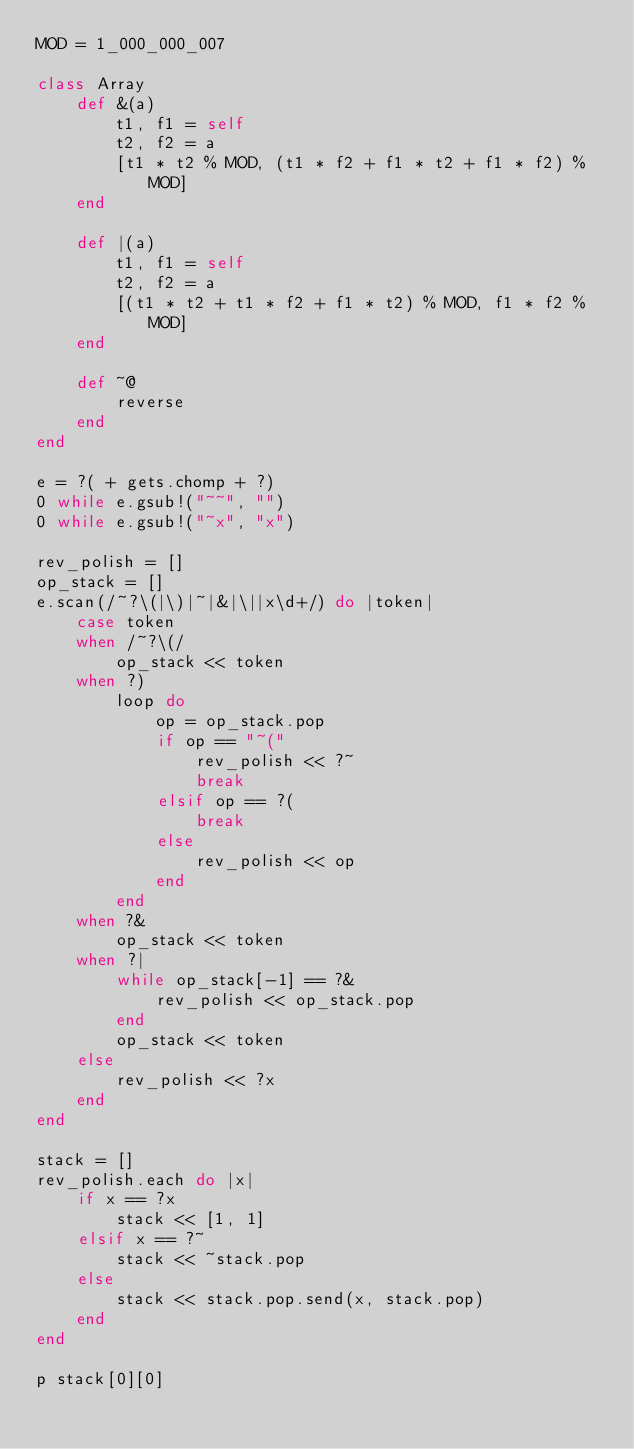Convert code to text. <code><loc_0><loc_0><loc_500><loc_500><_Ruby_>MOD = 1_000_000_007

class Array
	def &(a)
		t1, f1 = self
		t2, f2 = a
		[t1 * t2 % MOD, (t1 * f2 + f1 * t2 + f1 * f2) % MOD]
	end

	def |(a)
		t1, f1 = self
		t2, f2 = a
		[(t1 * t2 + t1 * f2 + f1 * t2) % MOD, f1 * f2 % MOD]
	end

	def ~@
		reverse	
	end
end

e = ?( + gets.chomp + ?)
0 while e.gsub!("~~", "")
0 while e.gsub!("~x", "x")

rev_polish = []
op_stack = []
e.scan(/~?\(|\)|~|&|\||x\d+/) do |token|
	case token
	when /~?\(/
		op_stack << token
	when ?)
		loop do
			op = op_stack.pop
			if op == "~("
				rev_polish << ?~
				break
			elsif op == ?(
				break
			else
				rev_polish << op
			end
		end
	when ?&
		op_stack << token
	when ?|
		while op_stack[-1] == ?&
			rev_polish << op_stack.pop
		end
		op_stack << token
	else
		rev_polish << ?x
	end
end

stack = []
rev_polish.each do |x|
	if x == ?x
		stack << [1, 1]
	elsif x == ?~
		stack << ~stack.pop
	else
		stack << stack.pop.send(x, stack.pop)
	end
end

p stack[0][0]</code> 